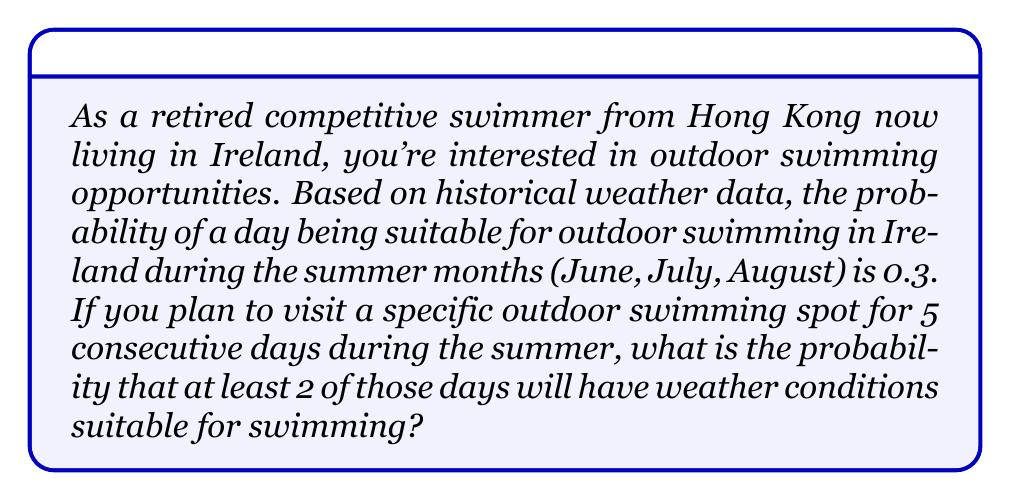Can you answer this question? Let's approach this step-by-step using the binomial probability distribution:

1) Let X be the number of days suitable for swimming out of the 5 days.
2) We want P(X ≥ 2), which is equivalent to 1 - P(X < 2) or 1 - [P(X = 0) + P(X = 1)].
3) The probability of success (suitable day) is p = 0.3, and the probability of failure (unsuitable day) is q = 1 - p = 0.7.
4) We can use the binomial probability formula:

   $$P(X = k) = \binom{n}{k} p^k (1-p)^{n-k}$$

   where n = 5 (total days) and k is the number of successes.

5) Calculate P(X = 0):
   $$P(X = 0) = \binom{5}{0} (0.3)^0 (0.7)^5 = 1 \cdot 1 \cdot 0.16807 = 0.16807$$

6) Calculate P(X = 1):
   $$P(X = 1) = \binom{5}{1} (0.3)^1 (0.7)^4 = 5 \cdot 0.3 \cdot 0.2401 = 0.36015$$

7) Therefore, P(X < 2) = P(X = 0) + P(X = 1) = 0.16807 + 0.36015 = 0.52822

8) Finally, P(X ≥ 2) = 1 - P(X < 2) = 1 - 0.52822 = 0.47178
Answer: The probability of having at least 2 days suitable for outdoor swimming during a 5-day period in summer in Ireland is approximately 0.47178 or 47.18%. 